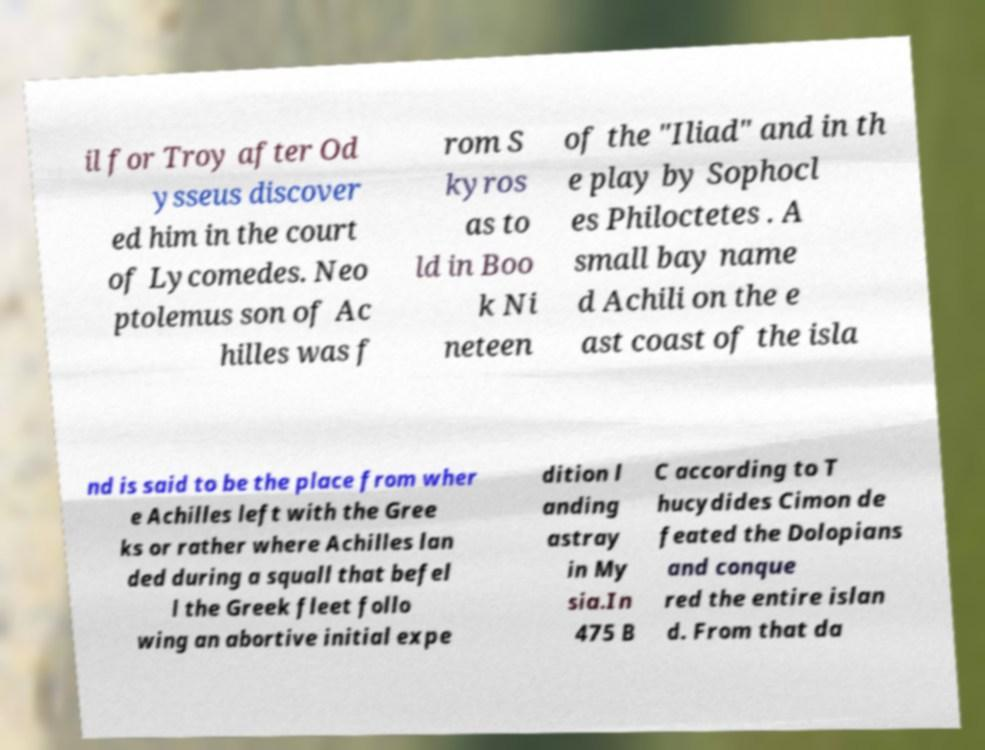Could you assist in decoding the text presented in this image and type it out clearly? il for Troy after Od ysseus discover ed him in the court of Lycomedes. Neo ptolemus son of Ac hilles was f rom S kyros as to ld in Boo k Ni neteen of the "Iliad" and in th e play by Sophocl es Philoctetes . A small bay name d Achili on the e ast coast of the isla nd is said to be the place from wher e Achilles left with the Gree ks or rather where Achilles lan ded during a squall that befel l the Greek fleet follo wing an abortive initial expe dition l anding astray in My sia.In 475 B C according to T hucydides Cimon de feated the Dolopians and conque red the entire islan d. From that da 